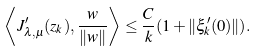Convert formula to latex. <formula><loc_0><loc_0><loc_500><loc_500>\left \langle J ^ { \prime } _ { \lambda , \mu } ( z _ { k } ) , \frac { w } { \| w \| } \right \rangle \leq \frac { C } { k } ( 1 + \| \xi _ { k } ^ { \prime } ( 0 ) \| ) .</formula> 